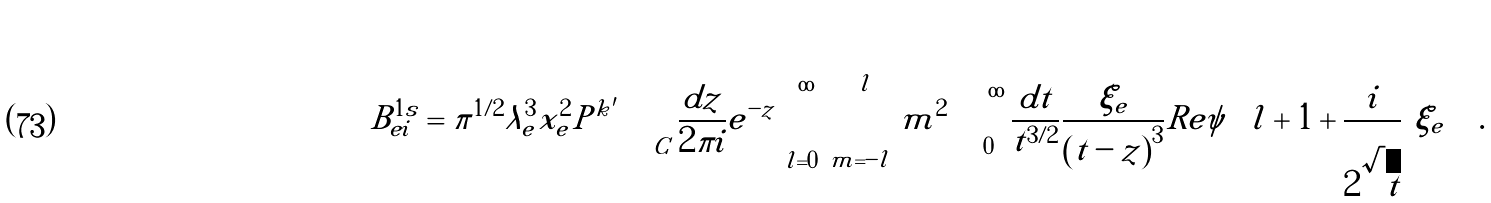Convert formula to latex. <formula><loc_0><loc_0><loc_500><loc_500>B ^ { 1 s } _ { e i } = \pi ^ { 1 / 2 } \lambda ^ { 3 } _ { e } x _ { e } ^ { 2 } { P } ^ { k ^ { \prime } } \int _ { C } \frac { d z } { 2 \pi i } e ^ { - z } \sum _ { l = 0 } ^ { \infty } \sum _ { m = - l } ^ { l } m ^ { 2 } \int _ { 0 } ^ { \infty } \frac { d t } { t ^ { 3 / 2 } } \frac { \xi _ { e } } { \left ( t - z \right ) ^ { 3 } } R e \psi \left ( l + 1 + \frac { i } { 2 \sqrt { t } } \left | \xi _ { e } \right | \right ) \, .</formula> 